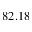<formula> <loc_0><loc_0><loc_500><loc_500>8 2 . 1 8</formula> 